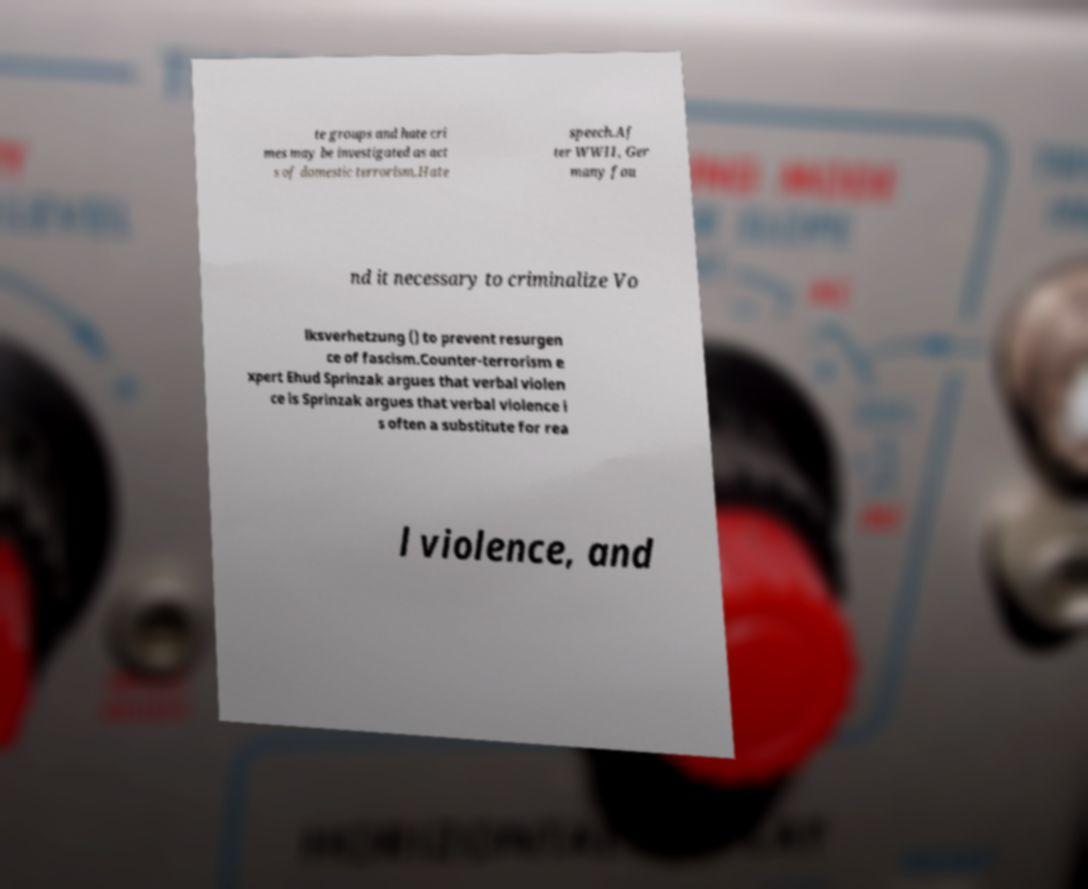There's text embedded in this image that I need extracted. Can you transcribe it verbatim? te groups and hate cri mes may be investigated as act s of domestic terrorism.Hate speech.Af ter WWII, Ger many fou nd it necessary to criminalize Vo lksverhetzung () to prevent resurgen ce of fascism.Counter-terrorism e xpert Ehud Sprinzak argues that verbal violen ce is Sprinzak argues that verbal violence i s often a substitute for rea l violence, and 